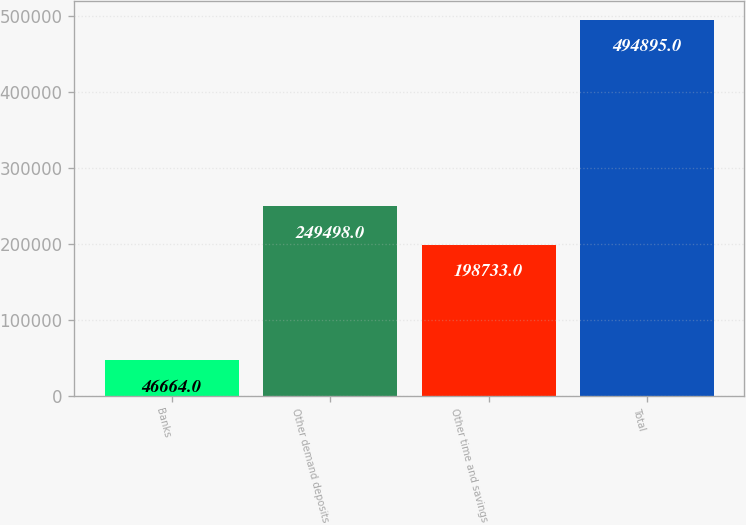Convert chart to OTSL. <chart><loc_0><loc_0><loc_500><loc_500><bar_chart><fcel>Banks<fcel>Other demand deposits<fcel>Other time and savings<fcel>Total<nl><fcel>46664<fcel>249498<fcel>198733<fcel>494895<nl></chart> 